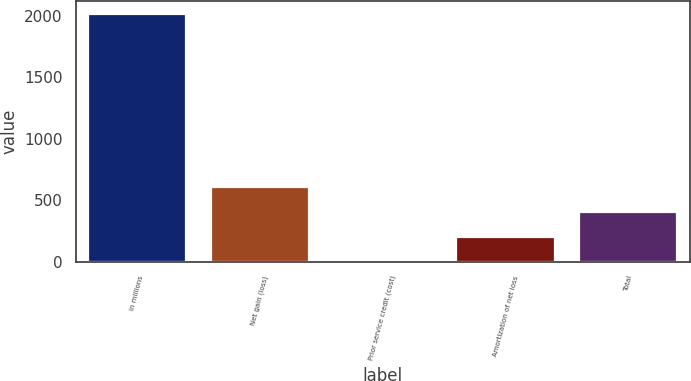Convert chart to OTSL. <chart><loc_0><loc_0><loc_500><loc_500><bar_chart><fcel>in millions<fcel>Net gain (loss)<fcel>Prior service credit (cost)<fcel>Amortization of net loss<fcel>Total<nl><fcel>2017<fcel>606.5<fcel>2<fcel>203.5<fcel>405<nl></chart> 